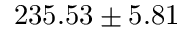Convert formula to latex. <formula><loc_0><loc_0><loc_500><loc_500>2 3 5 . 5 3 \pm 5 . 8 1</formula> 